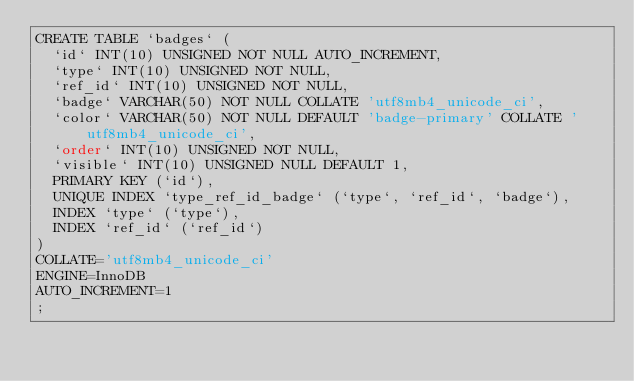<code> <loc_0><loc_0><loc_500><loc_500><_SQL_>CREATE TABLE `badges` (
	`id` INT(10) UNSIGNED NOT NULL AUTO_INCREMENT,
	`type` INT(10) UNSIGNED NOT NULL,
	`ref_id` INT(10) UNSIGNED NOT NULL,
	`badge` VARCHAR(50) NOT NULL COLLATE 'utf8mb4_unicode_ci',
	`color` VARCHAR(50) NOT NULL DEFAULT 'badge-primary' COLLATE 'utf8mb4_unicode_ci',
	`order` INT(10) UNSIGNED NOT NULL,
	`visible` INT(10) UNSIGNED NULL DEFAULT 1,
	PRIMARY KEY (`id`),
	UNIQUE INDEX `type_ref_id_badge` (`type`, `ref_id`, `badge`),
	INDEX `type` (`type`),
	INDEX `ref_id` (`ref_id`)
)
COLLATE='utf8mb4_unicode_ci'
ENGINE=InnoDB
AUTO_INCREMENT=1
;</code> 